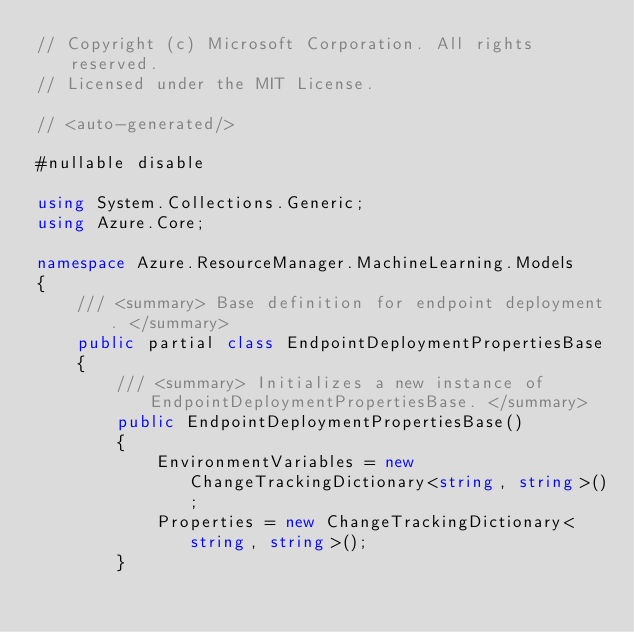<code> <loc_0><loc_0><loc_500><loc_500><_C#_>// Copyright (c) Microsoft Corporation. All rights reserved.
// Licensed under the MIT License.

// <auto-generated/>

#nullable disable

using System.Collections.Generic;
using Azure.Core;

namespace Azure.ResourceManager.MachineLearning.Models
{
    /// <summary> Base definition for endpoint deployment. </summary>
    public partial class EndpointDeploymentPropertiesBase
    {
        /// <summary> Initializes a new instance of EndpointDeploymentPropertiesBase. </summary>
        public EndpointDeploymentPropertiesBase()
        {
            EnvironmentVariables = new ChangeTrackingDictionary<string, string>();
            Properties = new ChangeTrackingDictionary<string, string>();
        }
</code> 